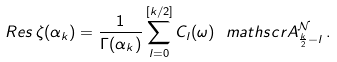<formula> <loc_0><loc_0><loc_500><loc_500>R e s \, \zeta ( \alpha _ { k } ) = \frac { 1 } { \Gamma ( \alpha _ { k } ) } \sum _ { l = 0 } ^ { [ k / 2 ] } C _ { l } ( \omega ) \ m a t h s c r { A } ^ { \mathcal { N } } _ { \frac { k } { 2 } - l } \, .</formula> 